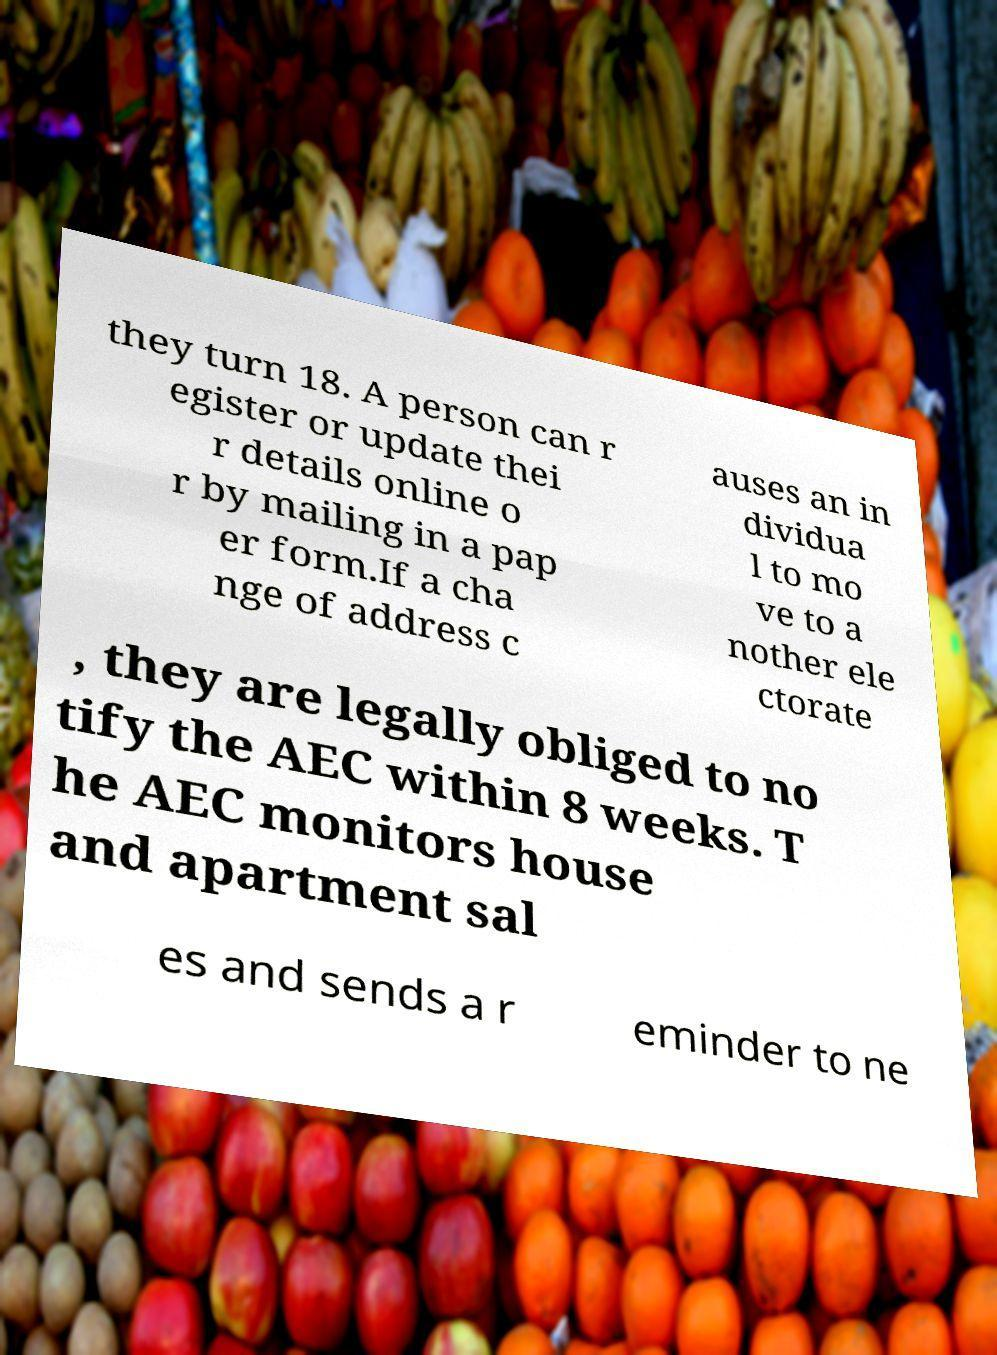Can you accurately transcribe the text from the provided image for me? they turn 18. A person can r egister or update thei r details online o r by mailing in a pap er form.If a cha nge of address c auses an in dividua l to mo ve to a nother ele ctorate , they are legally obliged to no tify the AEC within 8 weeks. T he AEC monitors house and apartment sal es and sends a r eminder to ne 